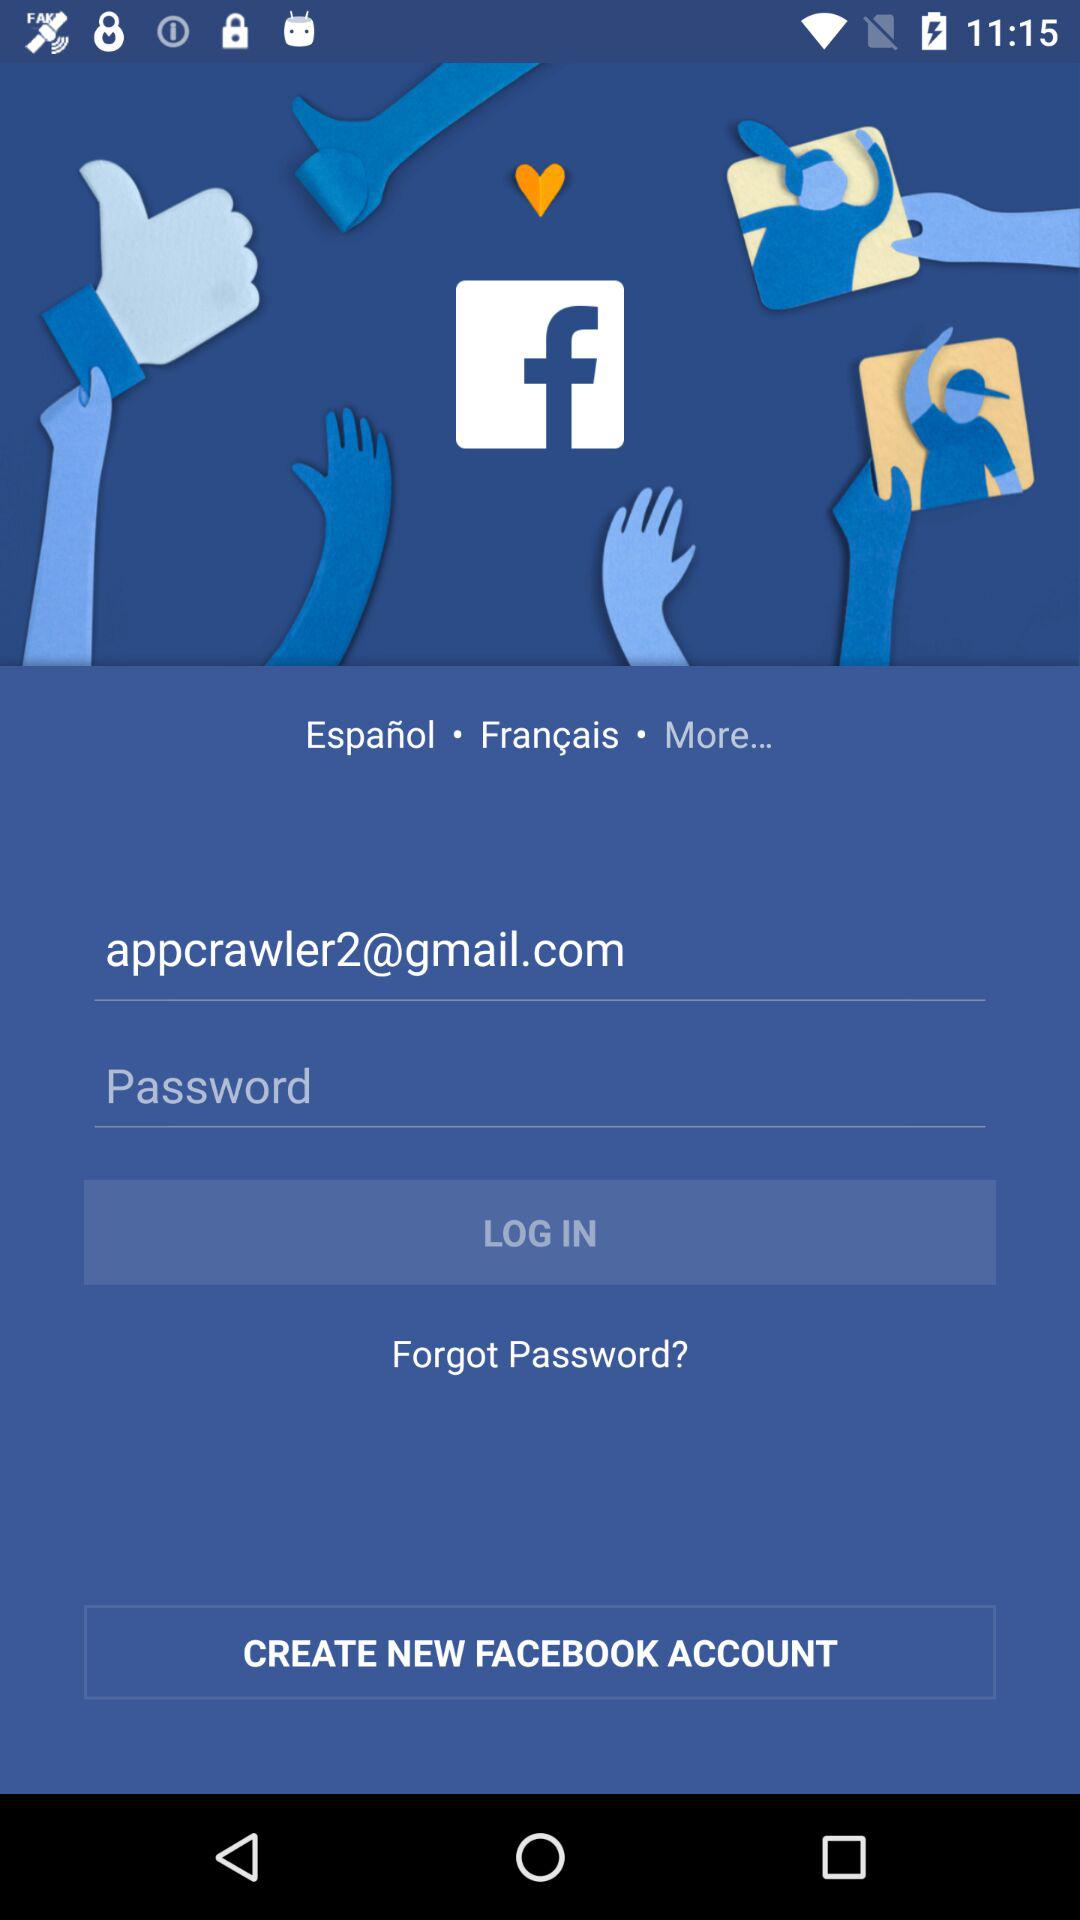What is the name of the application? The name of the application is "Facebook". 